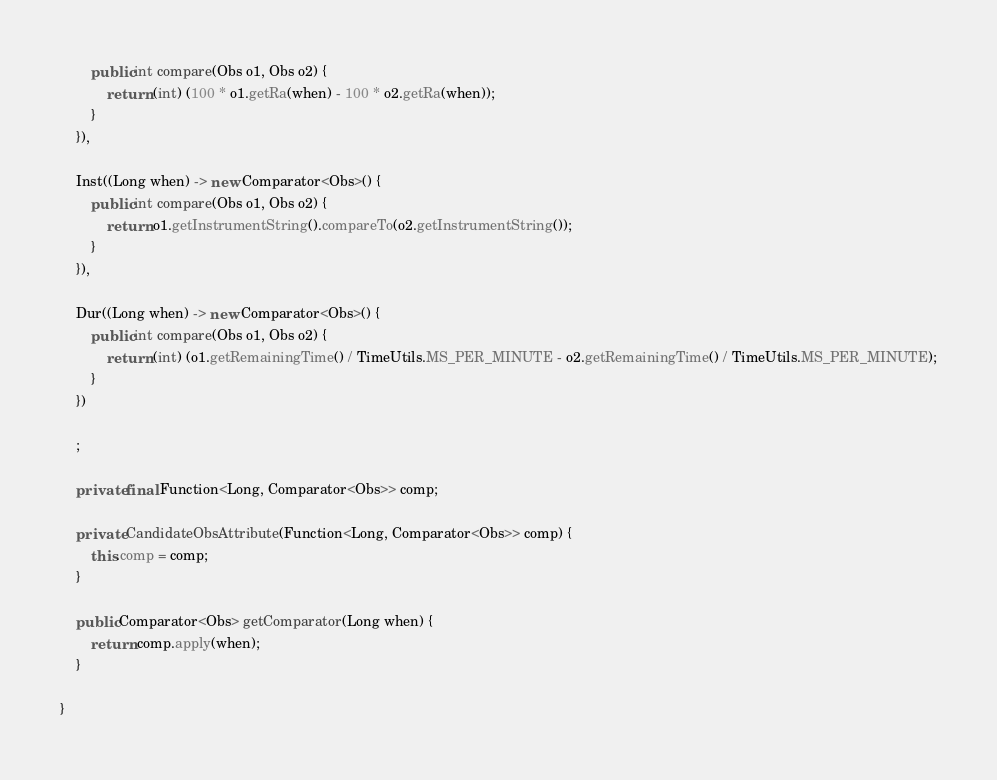<code> <loc_0><loc_0><loc_500><loc_500><_Java_>		public int compare(Obs o1, Obs o2) {
			return (int) (100 * o1.getRa(when) - 100 * o2.getRa(when));
		}
	}),

	Inst((Long when) -> new Comparator<Obs>() {
		public int compare(Obs o1, Obs o2) {
			return o1.getInstrumentString().compareTo(o2.getInstrumentString());
		}
	}), 
	
	Dur((Long when) -> new Comparator<Obs>() {
		public int compare(Obs o1, Obs o2) {
			return (int) (o1.getRemainingTime() / TimeUtils.MS_PER_MINUTE - o2.getRemainingTime() / TimeUtils.MS_PER_MINUTE);
		}
	})
	
	;
	
	private final Function<Long, Comparator<Obs>> comp;

	private CandidateObsAttribute(Function<Long, Comparator<Obs>> comp) {
		this.comp = comp;
	}

	public Comparator<Obs> getComparator(Long when) {
		return comp.apply(when);
	}
	
}
</code> 